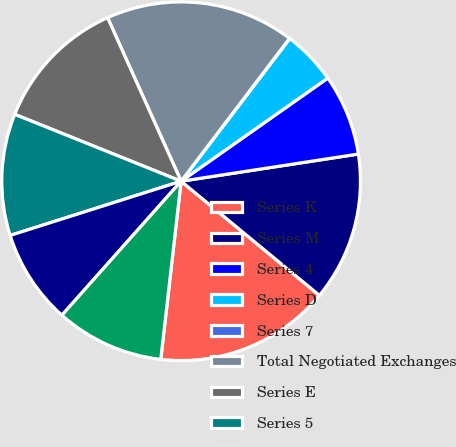Convert chart. <chart><loc_0><loc_0><loc_500><loc_500><pie_chart><fcel>Series K<fcel>Series M<fcel>Series 4<fcel>Series D<fcel>Series 7<fcel>Total Negotiated Exchanges<fcel>Series E<fcel>Series 5<fcel>Series 1<fcel>Series 2<nl><fcel>15.83%<fcel>13.4%<fcel>7.33%<fcel>4.89%<fcel>0.03%<fcel>17.05%<fcel>12.19%<fcel>10.97%<fcel>8.54%<fcel>9.76%<nl></chart> 